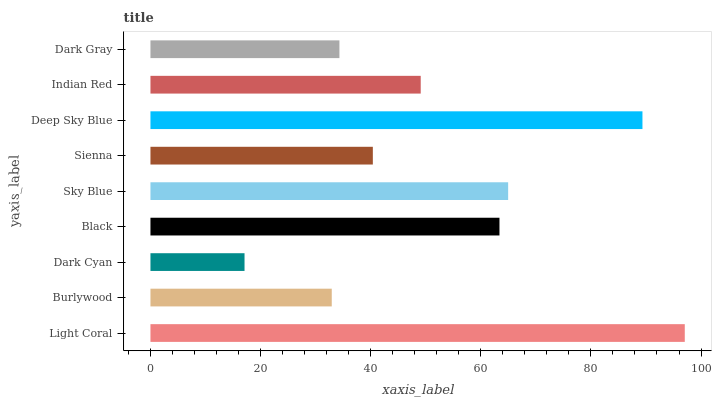Is Dark Cyan the minimum?
Answer yes or no. Yes. Is Light Coral the maximum?
Answer yes or no. Yes. Is Burlywood the minimum?
Answer yes or no. No. Is Burlywood the maximum?
Answer yes or no. No. Is Light Coral greater than Burlywood?
Answer yes or no. Yes. Is Burlywood less than Light Coral?
Answer yes or no. Yes. Is Burlywood greater than Light Coral?
Answer yes or no. No. Is Light Coral less than Burlywood?
Answer yes or no. No. Is Indian Red the high median?
Answer yes or no. Yes. Is Indian Red the low median?
Answer yes or no. Yes. Is Dark Gray the high median?
Answer yes or no. No. Is Dark Cyan the low median?
Answer yes or no. No. 